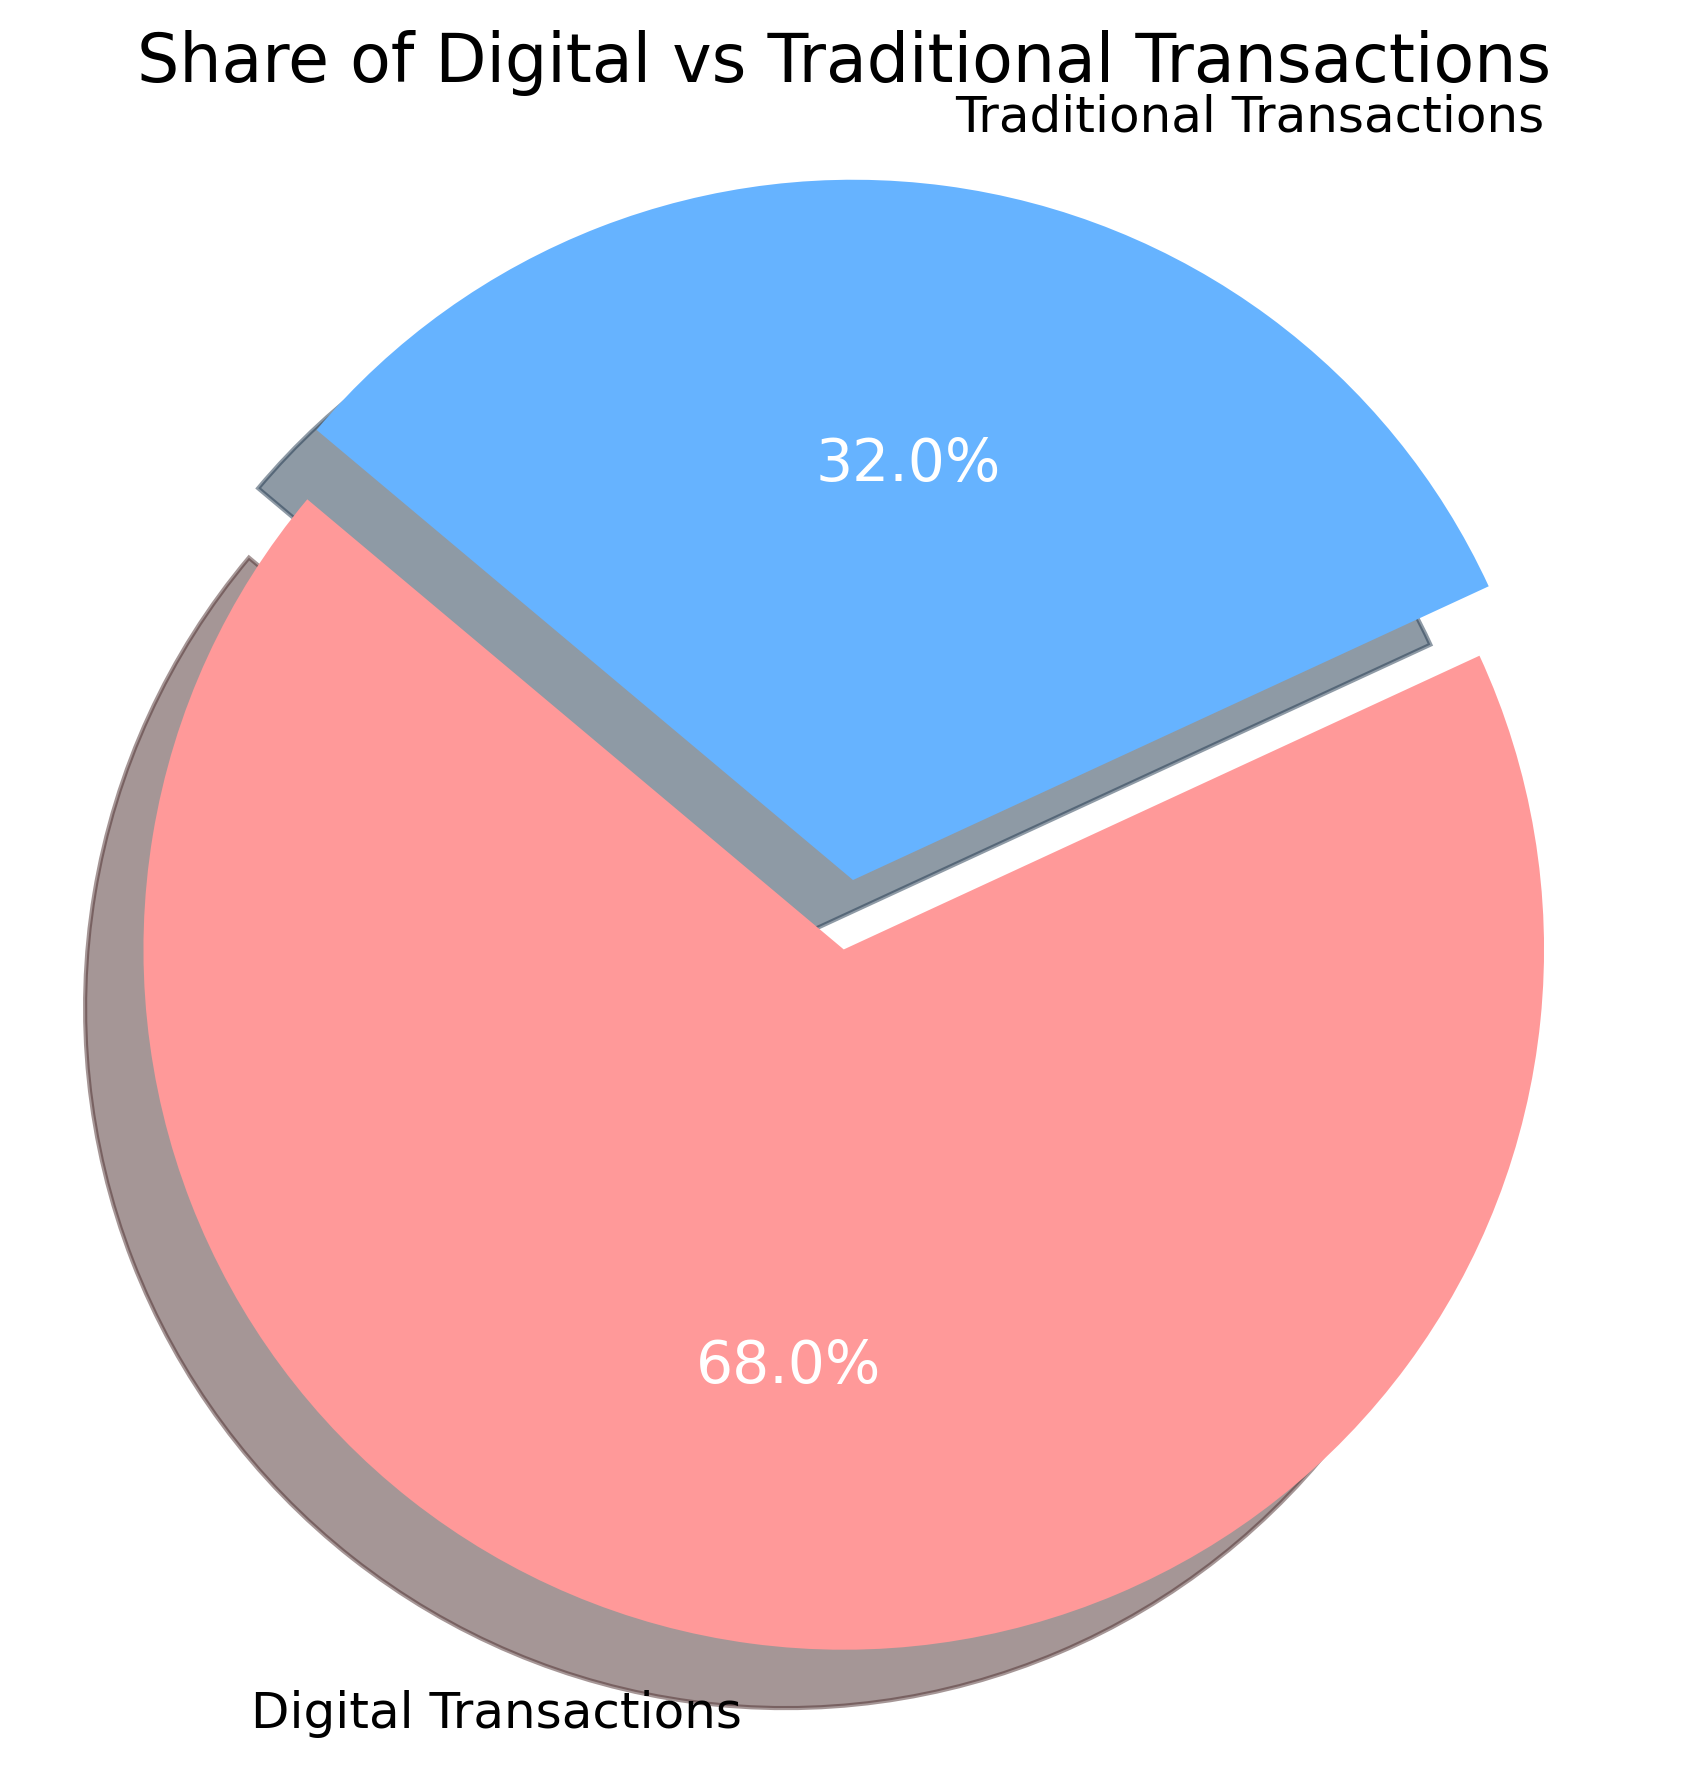What are the two categories represented in the pie chart? The pie chart represents two categories: Digital Transactions and Traditional Transactions. These categories are clearly labeled in the chart.
Answer: Digital Transactions and Traditional Transactions Which category has the larger share in the pie chart? By examining the size of the slices, it is evident that the slice for Digital Transactions is larger than the slice for Traditional Transactions.
Answer: Digital Transactions What percentage of transactions are digital? The percentage of Digital Transactions is labeled directly on the pie chart as 68.0%.
Answer: 68.0% If the total number of transactions is 1,000, how many of them are traditional transactions? To find this, calculate 32% of 1,000. \(0.32 \times 1000 = 320\). Therefore, there are 320 traditional transactions.
Answer: 320 Compare the slice colors of Digital and Traditional Transactions in the pie chart. What colors are used? The slice for Digital Transactions is shown in a red hue, while the slice for Traditional Transactions is shown in a blue hue. These colors visually separate the two categories.
Answer: Red for Digital Transactions and Blue for Traditional Transactions Estimate the difference in percentage points between Digital and Traditional Transactions based on the pie chart. Digital Transactions have 68%, and Traditional Transactions have 32%. The difference is \(68\% - 32\% = 36\%\).
Answer: 36% By how much must the percentage of Traditional Transactions increase to equal the percentage of Digital Transactions? To find this, we need an equal share. Each should be 50%. Traditional Transactions currently have 32%, so they must increase by \(50\% - 32\% = 18\%\).
Answer: 18% What is the sum of the percentages for Digital and Traditional Transactions? The sum of the shares is \(68\% + 32\% = 100\%\). This confirms that the pie chart represents the entire transaction distribution.
Answer: 100% If Digital Transactions decreased by 10%, what would their new percentage be? If Digital Transactions decrease by 10%, then their new share would be \( 68\% - 10\% = 58\% \).
Answer: 58% Given the current distribution, what fraction of the transactions are traditional, simplified to the lowest terms? Traditional Transactions are 32% of the total. The fraction is \( \frac{32}{100} \). Simplified, this is \( \frac{8}{25} \).
Answer: \( \frac{8}{25} \) 